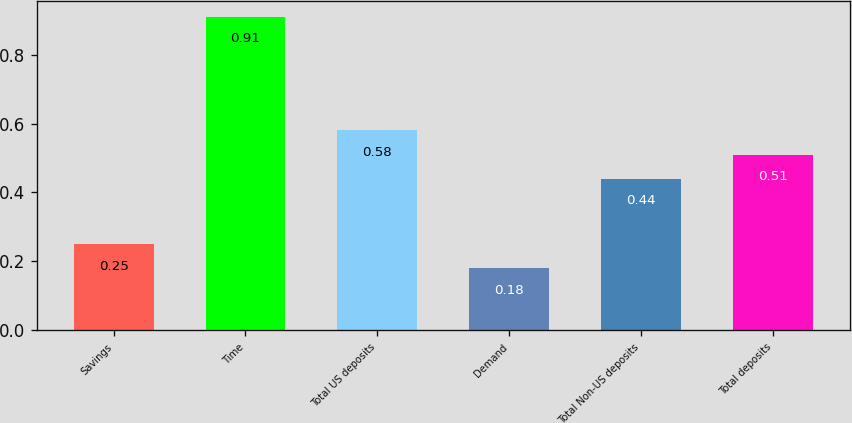<chart> <loc_0><loc_0><loc_500><loc_500><bar_chart><fcel>Savings<fcel>Time<fcel>Total US deposits<fcel>Demand<fcel>Total Non-US deposits<fcel>Total deposits<nl><fcel>0.25<fcel>0.91<fcel>0.58<fcel>0.18<fcel>0.44<fcel>0.51<nl></chart> 